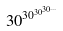Convert formula to latex. <formula><loc_0><loc_0><loc_500><loc_500>3 0 ^ { 3 0 ^ { 3 0 ^ { 3 0 ^ { \dots } } } }</formula> 